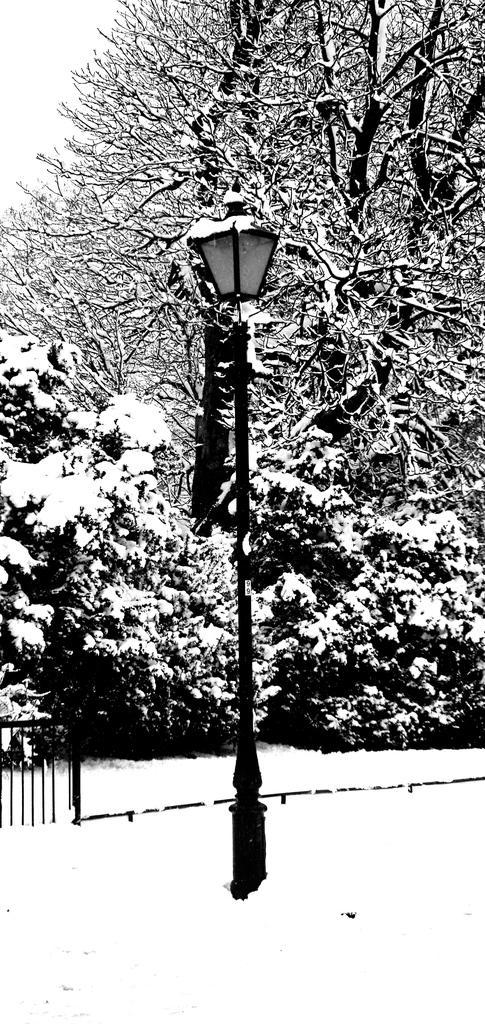In one or two sentences, can you explain what this image depicts? This is a black and white image where we can see the snowfall, light pole, fence and the trees covered with snow. 